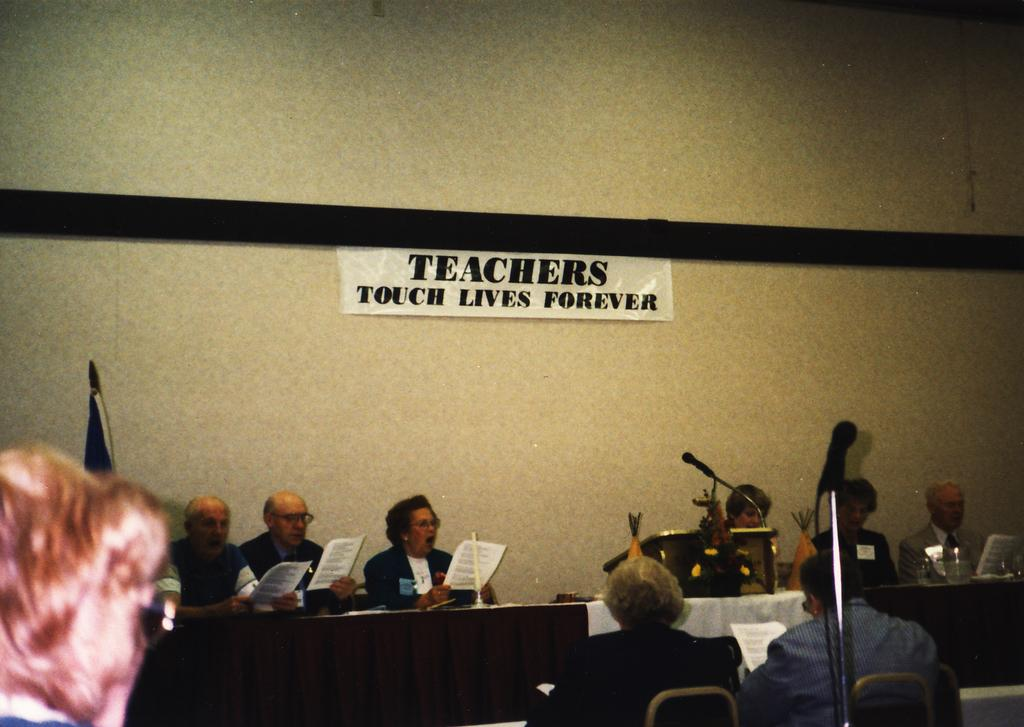What are the people in the image doing? The people in the image are sitting in front of a table. What are the people holding in the image? The people are holding papers in the image. What can be seen on the table in the image? There are objects placed on the table in the image. What device is present in the image that is used for amplifying sound? There is a microphone (mike) present in the image. What type of spark can be seen coming from the mountain in the image? There is no mountain present in the image, so there cannot be any spark coming from it. 